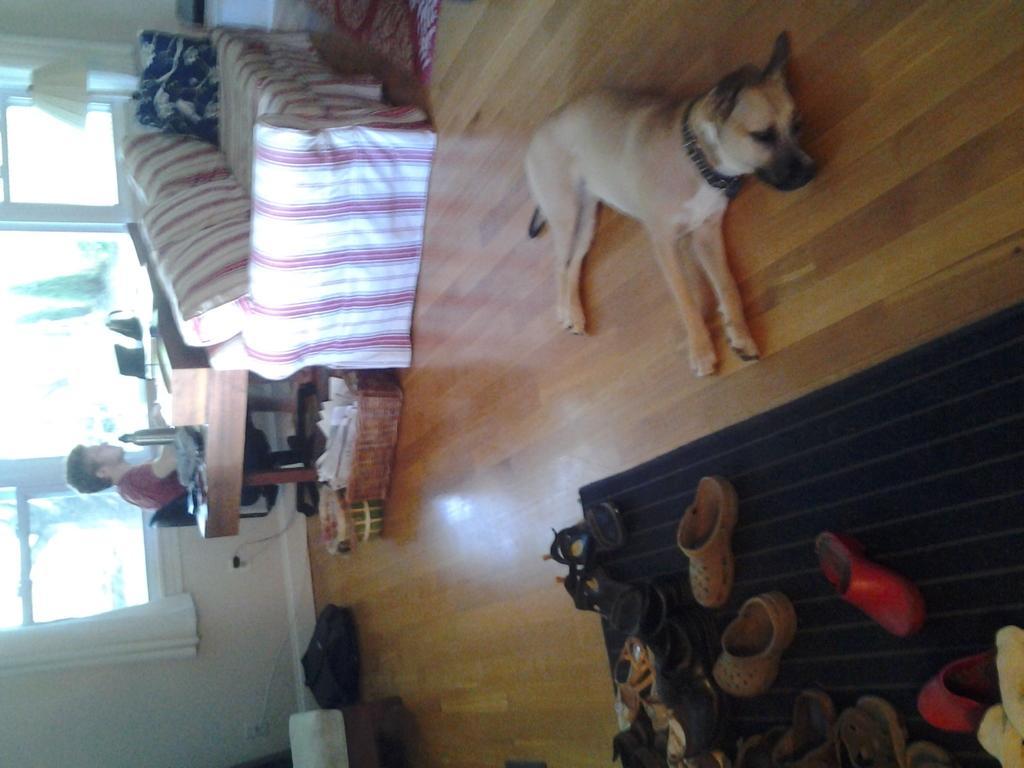Could you give a brief overview of what you see in this image? In this image there are windows and curtains in the left corner. There is a dog, a mat with foot wear on it in the right corner. There is a floor at the bottom. There is a table, chair, person and some objects on the table, sofas, pillows in the foreground. And there is a wall in the background. 